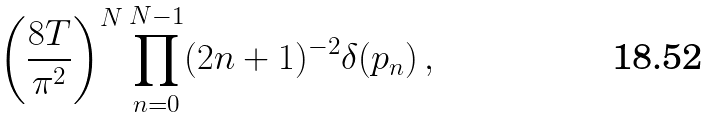<formula> <loc_0><loc_0><loc_500><loc_500>\left ( \frac { 8 T } { \pi ^ { 2 } } \right ) ^ { N } \prod _ { n = 0 } ^ { N - 1 } ( 2 n + 1 ) ^ { - 2 } \delta ( p _ { n } ) \, ,</formula> 